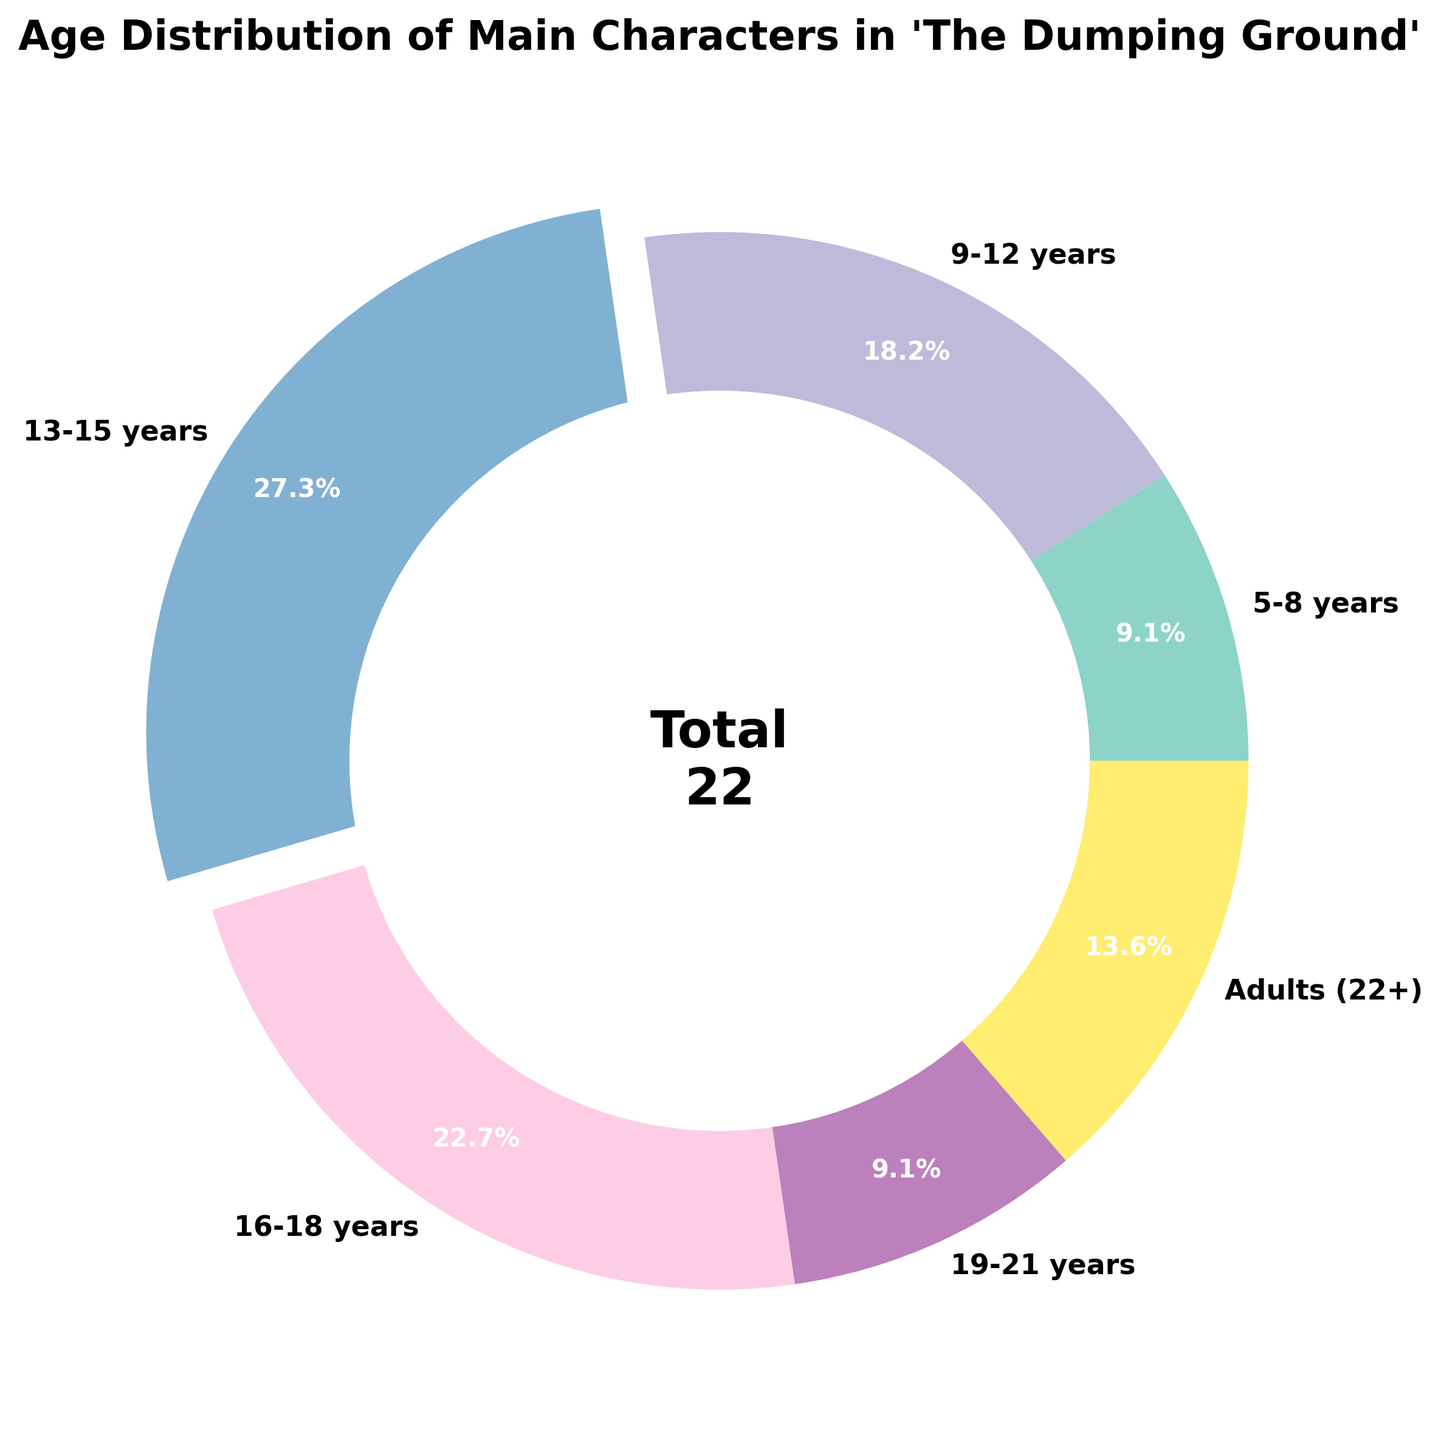Which age group has the largest share of main characters? The pie chart highlights the '13-15 years' age group with an exploded slice, making it easy to identify it as the largest group.
Answer: 13-15 years How many main characters are there in total in the series? The total number of characters is given in the figure's center, split across all age groups. Adding the values from each segment: 2 (5-8 years) + 4 (9-12 years) + 6 (13-15 years) + 5 (16-18 years) + 2 (19-21 years) + 3 (Adults 22+) = 22.
Answer: 22 Which age group has the smallest number of main characters? Looking at the proportion of each slice, the smallest sections are '5-8 years' and '19-21 years', each having just 2 characters.
Answer: 5-8 years and 19-21 years What percentage of main characters are between 16-18 years old? The slice for '16-18 years' is clearly labeled on the chart. The provided pie chart shows it as 5 out of 22 characters. To find the percentage: (5/22) * 100 ≈ 22.7%.
Answer: 22.7% How does the number of characters aged 13-15 compare with those aged 16-18? The chart shows '13-15 years' with 6 characters and '16-18 years' with 5 characters. Comparison: 6 (13-15) is greater than 5 (16-18).
Answer: More, by 1 character What is the combined percentage of characters aged between 9-12 years and adults (22+)? To find the combined percentage, add the number of characters in both groups: 4 (9-12 years) + 3 (adults, 22+) = 7. Calculate the percentage: (7/22) * 100 ≈ 31.8%.
Answer: 31.8% If one character from the '13-15 years' category were to move to the '16-18 years' category, how would the distribution change? Initially, '13-15 years' has 6 and '16-18 years' has 5 characters. After moving one character: '13-15 years' will have 5 and '16-18 years' will have 6. The new distribution would become equal for both groups.
Answer: Both groups will then have 5 and 6 characters respectively Which age groups have more characters, adults (22+) or 5-8 years? Comparing the two slices: 'Adults (22+)' has 3 characters, while '5-8 years' has 2 characters.
Answer: Adults (22+) What is the ratio of characters aged 9-12 years to those aged 19-21 years? The chart shows 4 characters in the '9-12 years' group and 2 in the '19-21 years' group. The ratio is 4:2, which simplifies to 2:1.
Answer: 2:1 